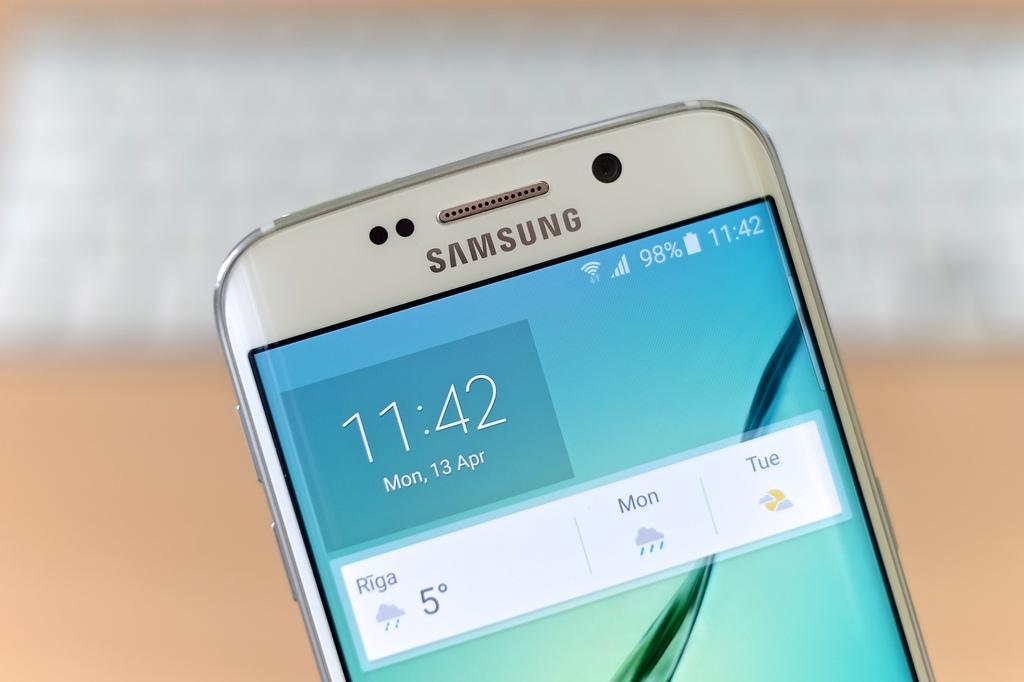What is the main object in the foreground of the image? There is a phone in the foreground of the image. What type of steam can be seen coming from the phone in the image? There is no steam visible in the image; it features a phone in the foreground. 